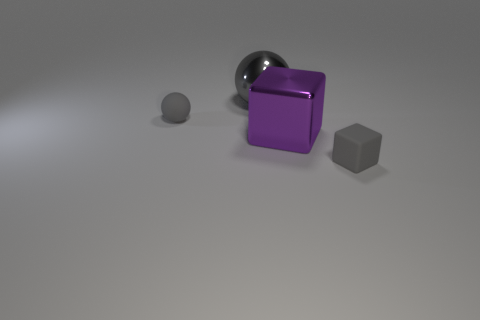Add 2 small gray objects. How many objects exist? 6 Subtract all small gray spheres. Subtract all gray matte cubes. How many objects are left? 2 Add 3 big purple metal blocks. How many big purple metal blocks are left? 4 Add 3 large gray things. How many large gray things exist? 4 Subtract 0 red cylinders. How many objects are left? 4 Subtract all gray cubes. Subtract all blue cylinders. How many cubes are left? 1 